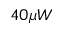Convert formula to latex. <formula><loc_0><loc_0><loc_500><loc_500>4 0 \mu W</formula> 